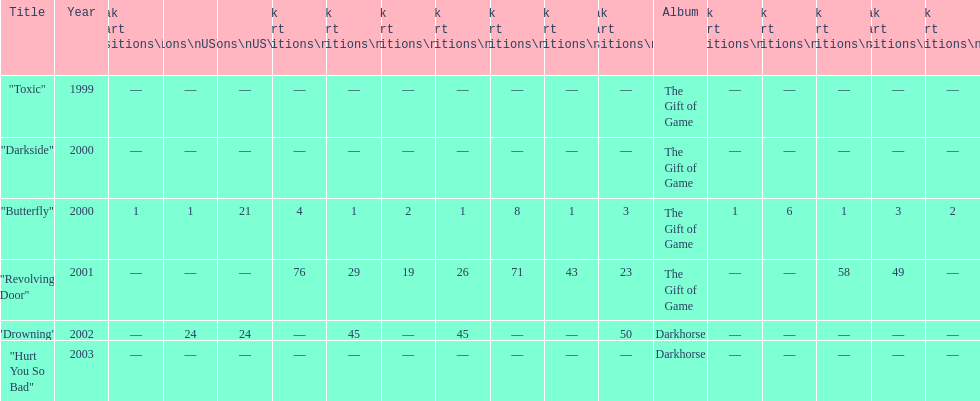Which single ranks 1 in us and 1 in us alt? "Butterfly". I'm looking to parse the entire table for insights. Could you assist me with that? {'header': ['Title', 'Year', 'Peak chart positions\\nUS', 'Peak chart positions\\nUS\\nAlt.', 'Peak chart positions\\nUS\\nMain. Rock', 'Peak chart positions\\nAUS', 'Peak chart positions\\nAUT', 'Peak chart positions\\nFIN', 'Peak chart positions\\nGER', 'Peak chart positions\\nNLD', 'Peak chart positions\\nSWI', 'Peak chart positions\\nUK', 'Album', 'Peak chart positions\\nCAN', 'Peak chart positions\\nFRA', 'Peak chart positions\\nIRE', 'Peak chart positions\\nNZ', 'Peak chart positions\\nSWE'], 'rows': [['"Toxic"', '1999', '—', '—', '—', '—', '—', '—', '—', '—', '—', '—', 'The Gift of Game', '—', '—', '—', '—', '—'], ['"Darkside"', '2000', '—', '—', '—', '—', '—', '—', '—', '—', '—', '—', 'The Gift of Game', '—', '—', '—', '—', '—'], ['"Butterfly"', '2000', '1', '1', '21', '4', '1', '2', '1', '8', '1', '3', 'The Gift of Game', '1', '6', '1', '3', '2'], ['"Revolving Door"', '2001', '—', '—', '—', '76', '29', '19', '26', '71', '43', '23', 'The Gift of Game', '—', '—', '58', '49', '—'], ['"Drowning"', '2002', '—', '24', '24', '—', '45', '—', '45', '—', '—', '50', 'Darkhorse', '—', '—', '—', '—', '—'], ['"Hurt You So Bad"', '2003', '—', '—', '—', '—', '—', '—', '—', '—', '—', '—', 'Darkhorse', '—', '—', '—', '—', '—']]} 